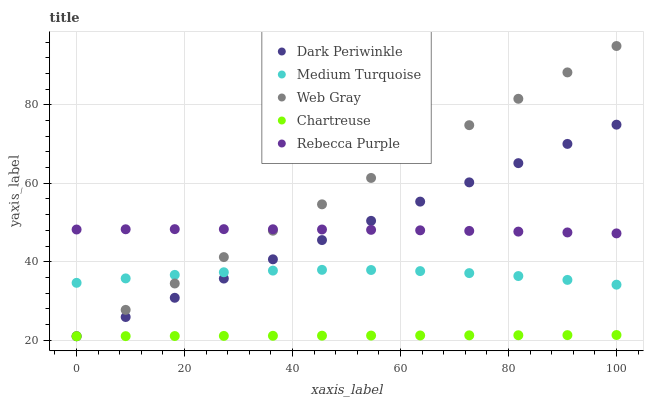Does Chartreuse have the minimum area under the curve?
Answer yes or no. Yes. Does Web Gray have the maximum area under the curve?
Answer yes or no. Yes. Does Dark Periwinkle have the minimum area under the curve?
Answer yes or no. No. Does Dark Periwinkle have the maximum area under the curve?
Answer yes or no. No. Is Chartreuse the smoothest?
Answer yes or no. Yes. Is Medium Turquoise the roughest?
Answer yes or no. Yes. Is Web Gray the smoothest?
Answer yes or no. No. Is Web Gray the roughest?
Answer yes or no. No. Does Chartreuse have the lowest value?
Answer yes or no. Yes. Does Medium Turquoise have the lowest value?
Answer yes or no. No. Does Web Gray have the highest value?
Answer yes or no. Yes. Does Dark Periwinkle have the highest value?
Answer yes or no. No. Is Medium Turquoise less than Rebecca Purple?
Answer yes or no. Yes. Is Medium Turquoise greater than Chartreuse?
Answer yes or no. Yes. Does Chartreuse intersect Dark Periwinkle?
Answer yes or no. Yes. Is Chartreuse less than Dark Periwinkle?
Answer yes or no. No. Is Chartreuse greater than Dark Periwinkle?
Answer yes or no. No. Does Medium Turquoise intersect Rebecca Purple?
Answer yes or no. No. 